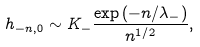Convert formula to latex. <formula><loc_0><loc_0><loc_500><loc_500>h _ { - n , 0 } \sim K _ { - } \frac { \exp \left ( - n / \lambda _ { - } \right ) } { n ^ { 1 / 2 } } ,</formula> 